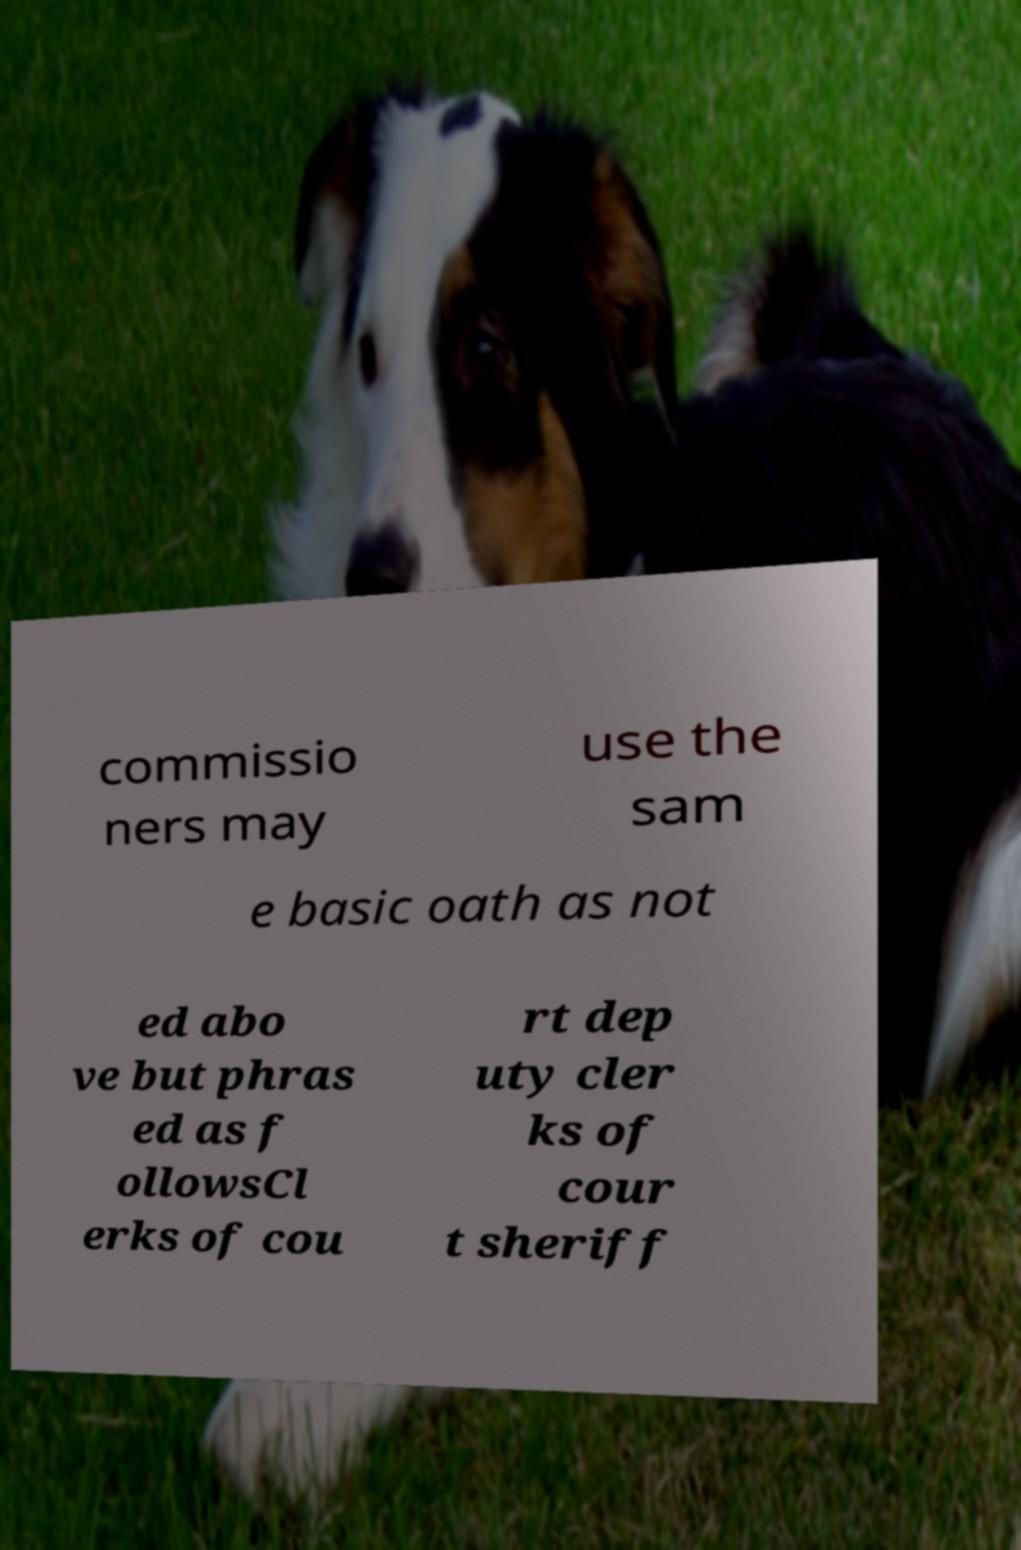I need the written content from this picture converted into text. Can you do that? commissio ners may use the sam e basic oath as not ed abo ve but phras ed as f ollowsCl erks of cou rt dep uty cler ks of cour t sheriff 